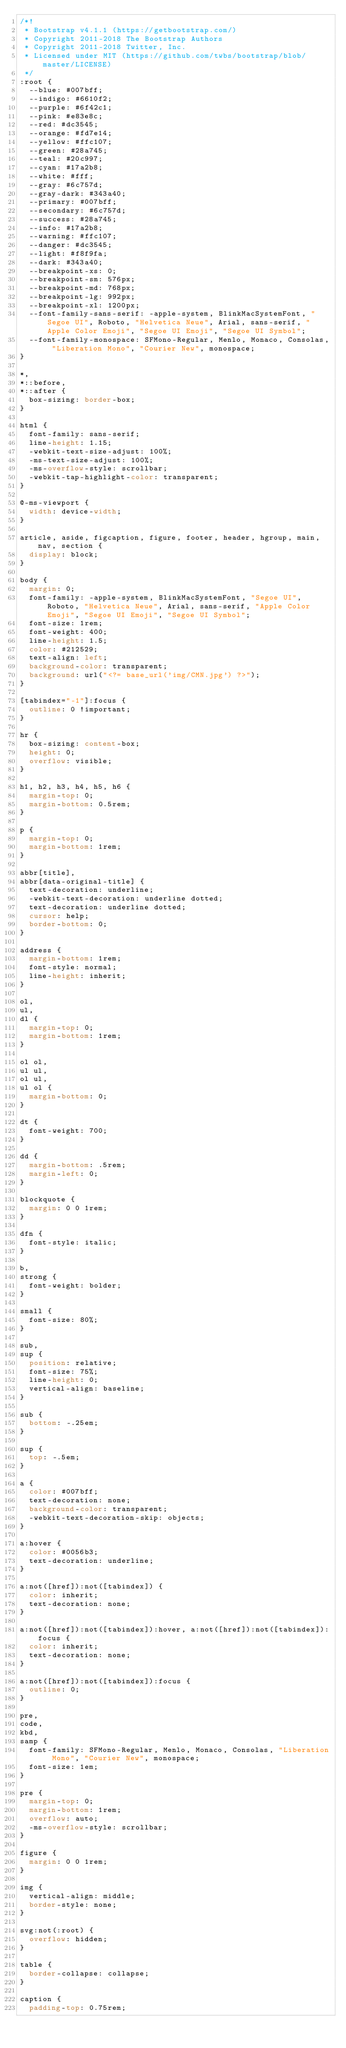Convert code to text. <code><loc_0><loc_0><loc_500><loc_500><_CSS_>/*!
 * Bootstrap v4.1.1 (https://getbootstrap.com/)
 * Copyright 2011-2018 The Bootstrap Authors
 * Copyright 2011-2018 Twitter, Inc.
 * Licensed under MIT (https://github.com/twbs/bootstrap/blob/master/LICENSE)
 */
:root {
  --blue: #007bff;
  --indigo: #6610f2;
  --purple: #6f42c1;
  --pink: #e83e8c;
  --red: #dc3545;
  --orange: #fd7e14;
  --yellow: #ffc107;
  --green: #28a745;
  --teal: #20c997;
  --cyan: #17a2b8;
  --white: #fff;
  --gray: #6c757d;
  --gray-dark: #343a40;
  --primary: #007bff;
  --secondary: #6c757d;
  --success: #28a745;
  --info: #17a2b8;
  --warning: #ffc107;
  --danger: #dc3545;
  --light: #f8f9fa;
  --dark: #343a40;
  --breakpoint-xs: 0;
  --breakpoint-sm: 576px;
  --breakpoint-md: 768px;
  --breakpoint-lg: 992px;
  --breakpoint-xl: 1200px;
  --font-family-sans-serif: -apple-system, BlinkMacSystemFont, "Segoe UI", Roboto, "Helvetica Neue", Arial, sans-serif, "Apple Color Emoji", "Segoe UI Emoji", "Segoe UI Symbol";
  --font-family-monospace: SFMono-Regular, Menlo, Monaco, Consolas, "Liberation Mono", "Courier New", monospace;
}

*,
*::before,
*::after {
  box-sizing: border-box;
}

html {
  font-family: sans-serif;
  line-height: 1.15;
  -webkit-text-size-adjust: 100%;
  -ms-text-size-adjust: 100%;
  -ms-overflow-style: scrollbar;
  -webkit-tap-highlight-color: transparent;
}

@-ms-viewport {
  width: device-width;
}

article, aside, figcaption, figure, footer, header, hgroup, main, nav, section {
  display: block;
}

body {
  margin: 0;
  font-family: -apple-system, BlinkMacSystemFont, "Segoe UI", Roboto, "Helvetica Neue", Arial, sans-serif, "Apple Color Emoji", "Segoe UI Emoji", "Segoe UI Symbol";
  font-size: 1rem;
  font-weight: 400;
  line-height: 1.5;
  color: #212529;
  text-align: left;
  background-color: transparent;
  background: url("<?= base_url('img/CMN.jpg') ?>");
}

[tabindex="-1"]:focus {
  outline: 0 !important;
}

hr {
  box-sizing: content-box;
  height: 0;
  overflow: visible;
}

h1, h2, h3, h4, h5, h6 {
  margin-top: 0;
  margin-bottom: 0.5rem;
}

p {
  margin-top: 0;
  margin-bottom: 1rem;
}

abbr[title],
abbr[data-original-title] {
  text-decoration: underline;
  -webkit-text-decoration: underline dotted;
  text-decoration: underline dotted;
  cursor: help;
  border-bottom: 0;
}

address {
  margin-bottom: 1rem;
  font-style: normal;
  line-height: inherit;
}

ol,
ul,
dl {
  margin-top: 0;
  margin-bottom: 1rem;
}

ol ol,
ul ul,
ol ul,
ul ol {
  margin-bottom: 0;
}

dt {
  font-weight: 700;
}

dd {
  margin-bottom: .5rem;
  margin-left: 0;
}

blockquote {
  margin: 0 0 1rem;
}

dfn {
  font-style: italic;
}

b,
strong {
  font-weight: bolder;
}

small {
  font-size: 80%;
}

sub,
sup {
  position: relative;
  font-size: 75%;
  line-height: 0;
  vertical-align: baseline;
}

sub {
  bottom: -.25em;
}

sup {
  top: -.5em;
}

a {
  color: #007bff;
  text-decoration: none;
  background-color: transparent;
  -webkit-text-decoration-skip: objects;
}

a:hover {
  color: #0056b3;
  text-decoration: underline;
}

a:not([href]):not([tabindex]) {
  color: inherit;
  text-decoration: none;
}

a:not([href]):not([tabindex]):hover, a:not([href]):not([tabindex]):focus {
  color: inherit;
  text-decoration: none;
}

a:not([href]):not([tabindex]):focus {
  outline: 0;
}

pre,
code,
kbd,
samp {
  font-family: SFMono-Regular, Menlo, Monaco, Consolas, "Liberation Mono", "Courier New", monospace;
  font-size: 1em;
}

pre {
  margin-top: 0;
  margin-bottom: 1rem;
  overflow: auto;
  -ms-overflow-style: scrollbar;
}

figure {
  margin: 0 0 1rem;
}

img {
  vertical-align: middle;
  border-style: none;
}

svg:not(:root) {
  overflow: hidden;
}

table {
  border-collapse: collapse;
}

caption {
  padding-top: 0.75rem;</code> 